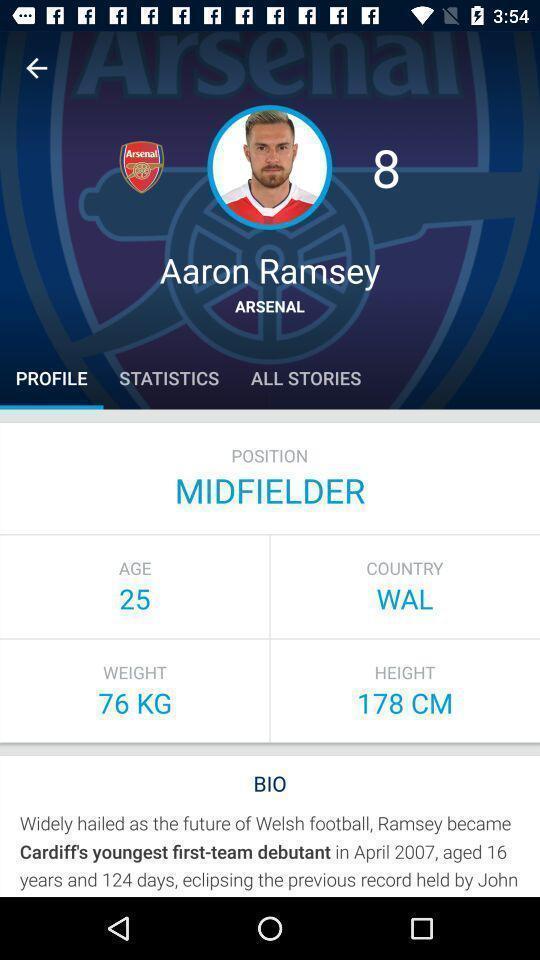What is the overall content of this screenshot? Profile of a player in a league. 